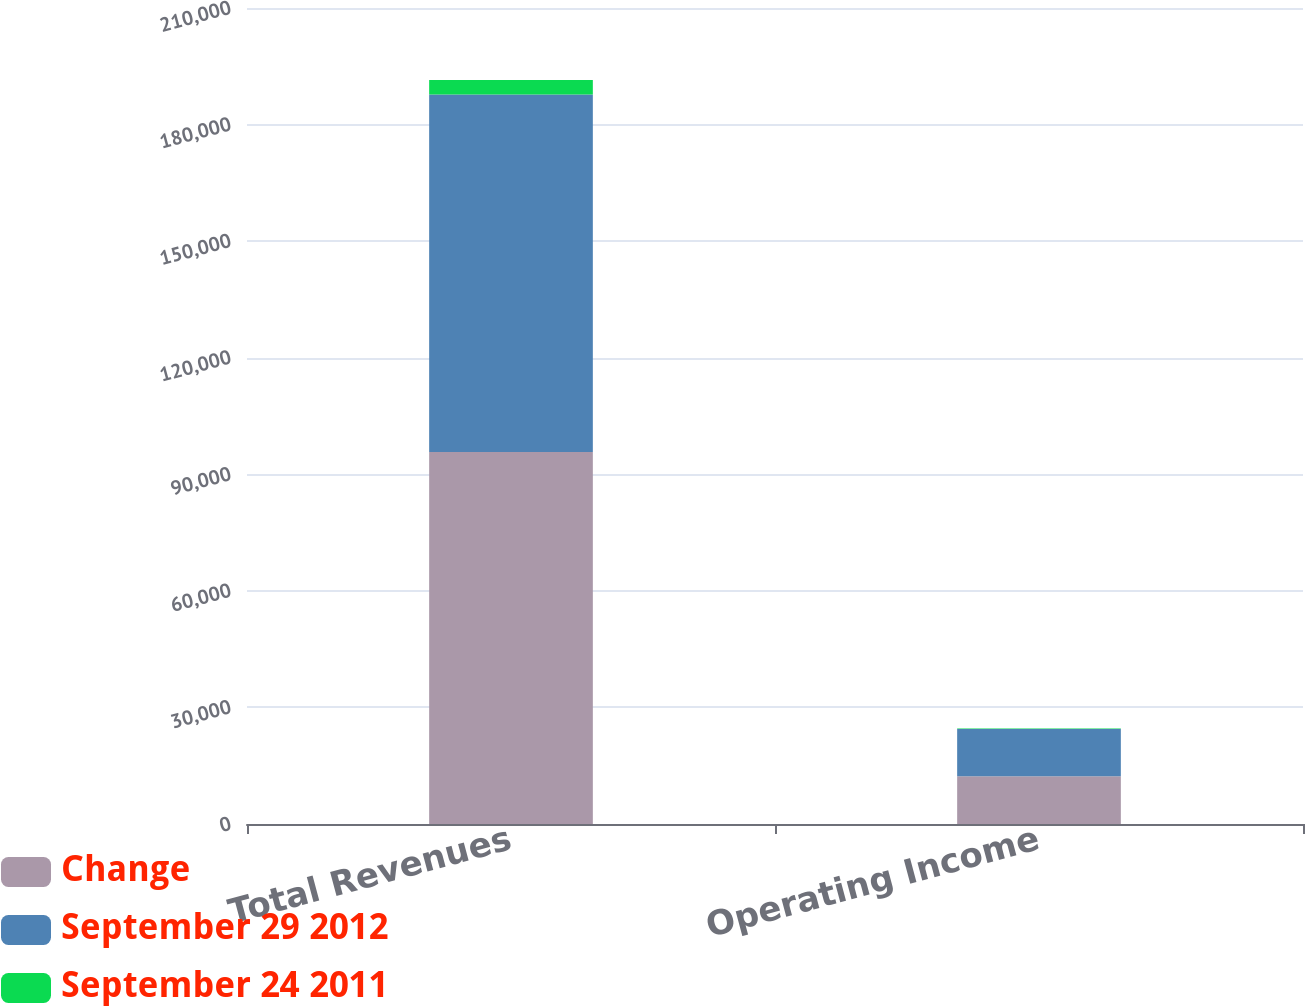<chart> <loc_0><loc_0><loc_500><loc_500><stacked_bar_chart><ecel><fcel>Total Revenues<fcel>Operating Income<nl><fcel>Change<fcel>95728<fcel>12290<nl><fcel>September 29 2012<fcel>91997<fcel>12159<nl><fcel>September 24 2011<fcel>3731<fcel>131<nl></chart> 